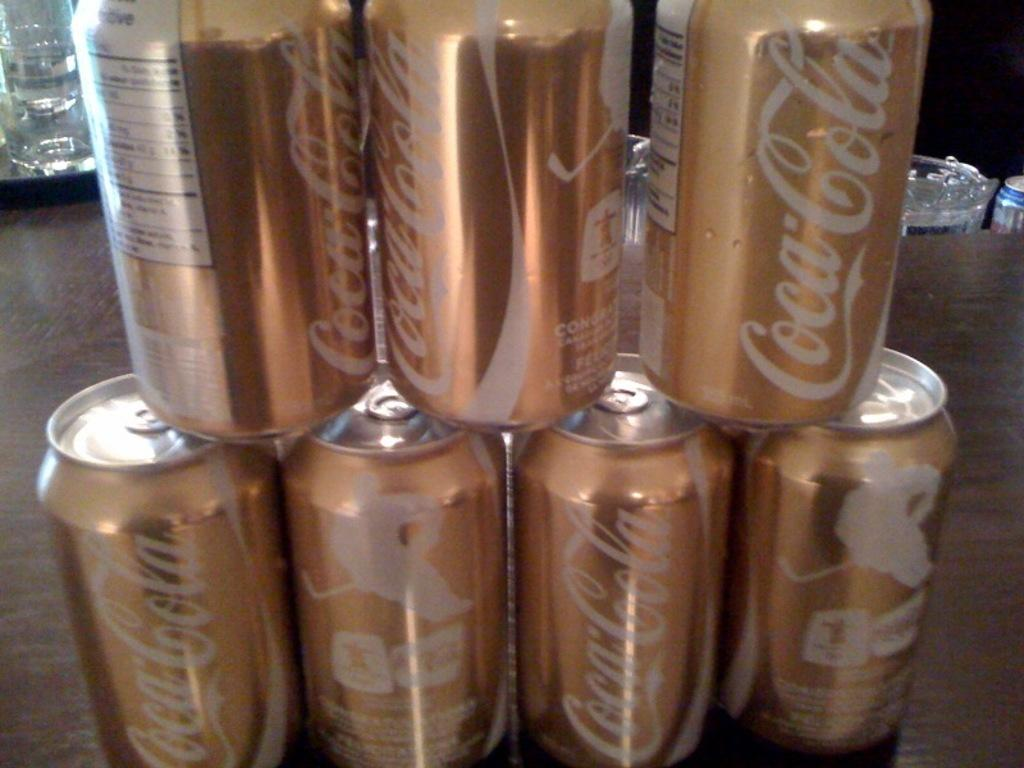<image>
Offer a succinct explanation of the picture presented. Gold colored cans of Coca-Cola are stacked in two rows. 